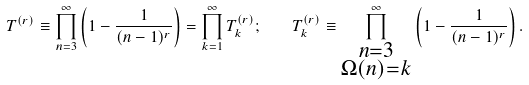<formula> <loc_0><loc_0><loc_500><loc_500>T ^ { ( r ) } \equiv \prod _ { n = 3 } ^ { \infty } \left ( 1 - \frac { 1 } { ( n - 1 ) ^ { r } } \right ) = \prod _ { k = 1 } ^ { \infty } T _ { k } ^ { ( r ) } ; \quad T _ { k } ^ { ( r ) } \equiv \prod _ { \substack { n = 3 \\ \Omega ( n ) = k } } ^ { \infty } \left ( 1 - \frac { 1 } { ( n - 1 ) ^ { r } } \right ) .</formula> 